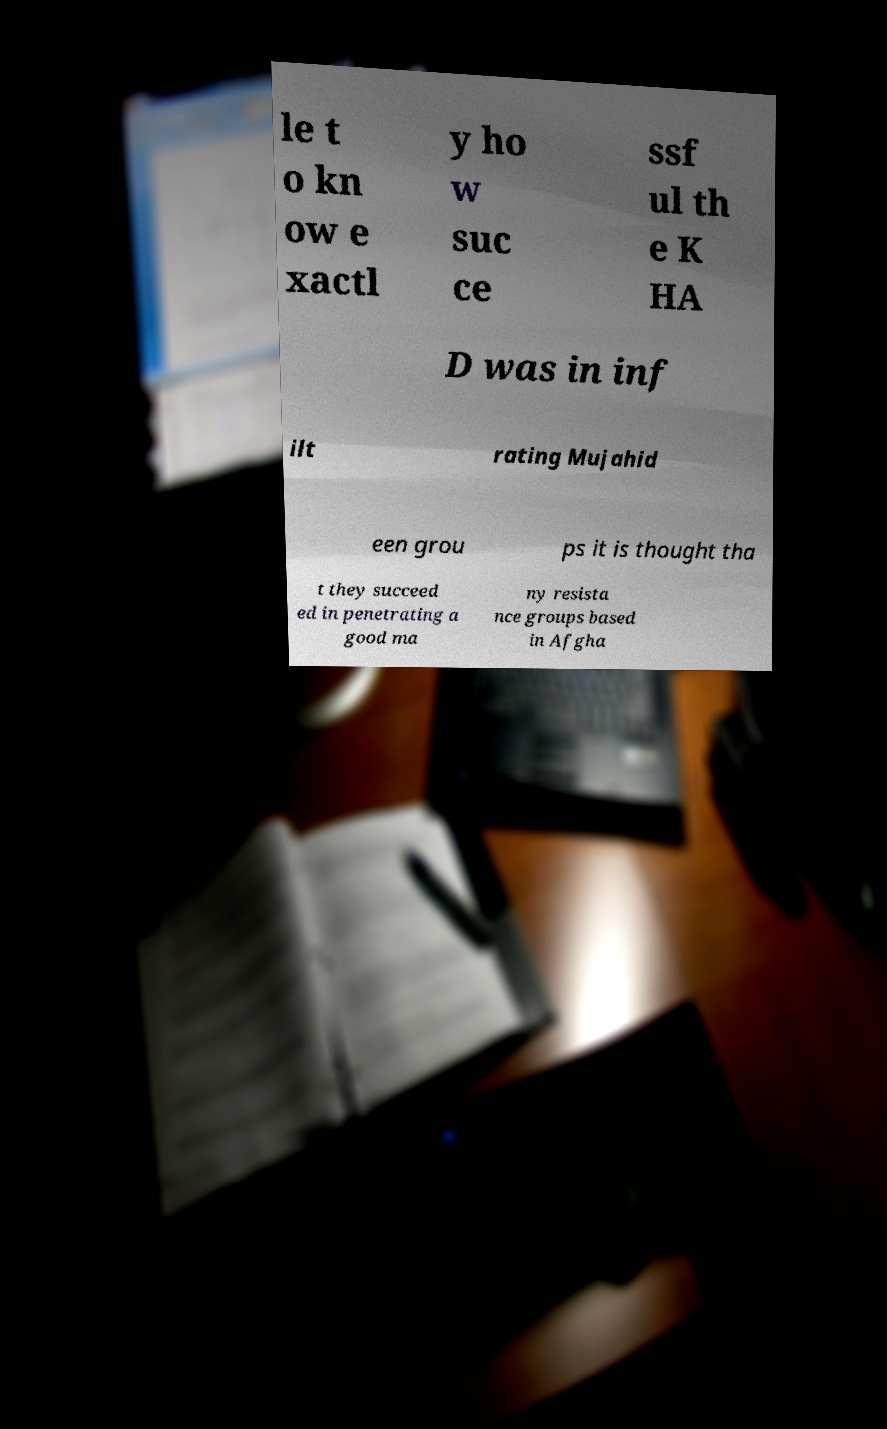Could you extract and type out the text from this image? le t o kn ow e xactl y ho w suc ce ssf ul th e K HA D was in inf ilt rating Mujahid een grou ps it is thought tha t they succeed ed in penetrating a good ma ny resista nce groups based in Afgha 